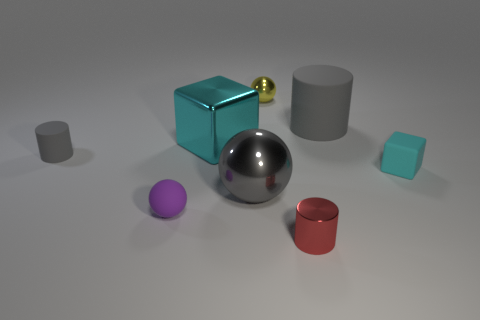There is a block in front of the gray matte cylinder that is on the left side of the large gray sphere; what is its size?
Your response must be concise. Small. There is a big metallic object that is in front of the tiny gray object; is its shape the same as the red metallic thing?
Give a very brief answer. No. What material is the tiny yellow thing that is the same shape as the gray metal thing?
Keep it short and to the point. Metal. How many things are cyan things to the left of the red object or rubber things that are in front of the small gray matte thing?
Make the answer very short. 3. Is the color of the metal cylinder the same as the metallic ball behind the big matte object?
Ensure brevity in your answer.  No. There is a big gray object that is the same material as the purple ball; what shape is it?
Offer a very short reply. Cylinder. How many tiny yellow shiny things are there?
Provide a succinct answer. 1. What number of things are metal things that are on the left side of the shiny cylinder or purple matte objects?
Your answer should be very brief. 4. Do the small ball that is left of the gray shiny ball and the metal cylinder have the same color?
Your answer should be very brief. No. What number of other objects are the same color as the large metallic cube?
Your answer should be compact. 1. 